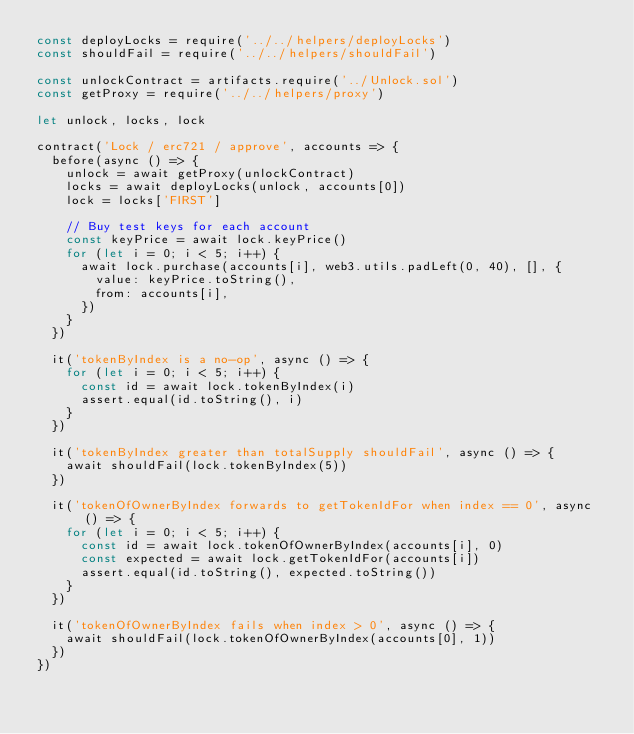<code> <loc_0><loc_0><loc_500><loc_500><_JavaScript_>const deployLocks = require('../../helpers/deployLocks')
const shouldFail = require('../../helpers/shouldFail')

const unlockContract = artifacts.require('../Unlock.sol')
const getProxy = require('../../helpers/proxy')

let unlock, locks, lock

contract('Lock / erc721 / approve', accounts => {
  before(async () => {
    unlock = await getProxy(unlockContract)
    locks = await deployLocks(unlock, accounts[0])
    lock = locks['FIRST']

    // Buy test keys for each account
    const keyPrice = await lock.keyPrice()
    for (let i = 0; i < 5; i++) {
      await lock.purchase(accounts[i], web3.utils.padLeft(0, 40), [], {
        value: keyPrice.toString(),
        from: accounts[i],
      })
    }
  })

  it('tokenByIndex is a no-op', async () => {
    for (let i = 0; i < 5; i++) {
      const id = await lock.tokenByIndex(i)
      assert.equal(id.toString(), i)
    }
  })

  it('tokenByIndex greater than totalSupply shouldFail', async () => {
    await shouldFail(lock.tokenByIndex(5))
  })

  it('tokenOfOwnerByIndex forwards to getTokenIdFor when index == 0', async () => {
    for (let i = 0; i < 5; i++) {
      const id = await lock.tokenOfOwnerByIndex(accounts[i], 0)
      const expected = await lock.getTokenIdFor(accounts[i])
      assert.equal(id.toString(), expected.toString())
    }
  })

  it('tokenOfOwnerByIndex fails when index > 0', async () => {
    await shouldFail(lock.tokenOfOwnerByIndex(accounts[0], 1))
  })
})
</code> 